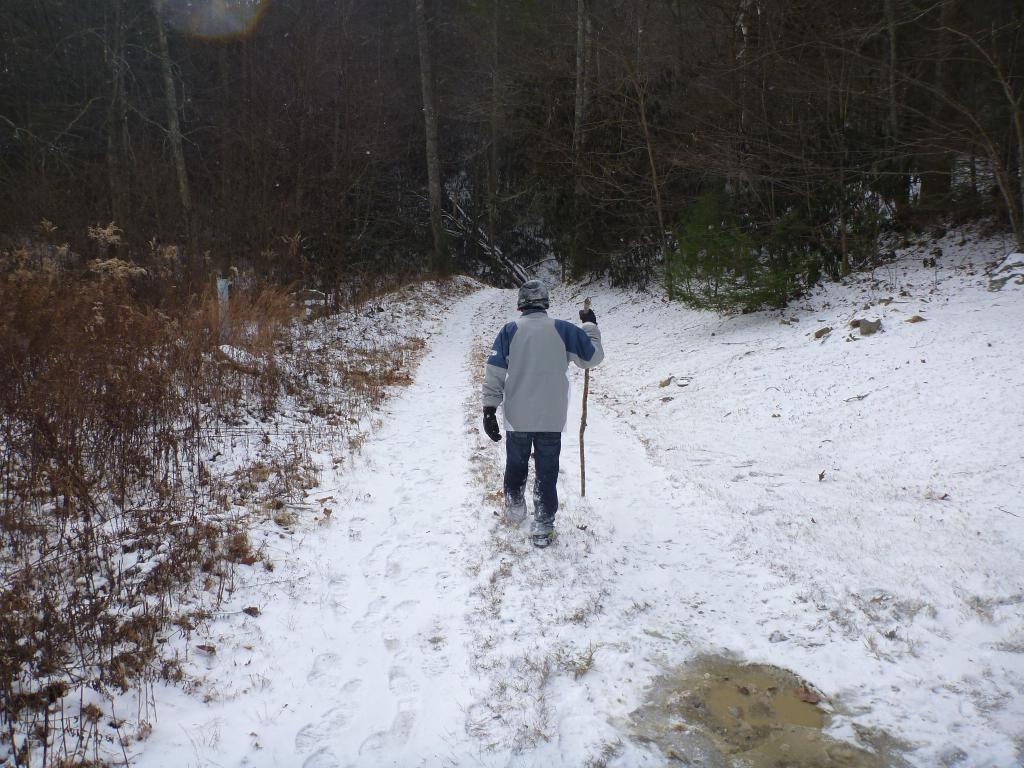Who is present in the image? There is a man in the image. What is the man doing in the image? The man is walking in the snow. What object is the man holding in the image? The man is holding a stick. What can be seen in the background of the image? There are trees in the background of the image. What type of feather can be seen floating in the air in the image? There is no feather present in the image; it features a man walking in the snow while holding a stick. 